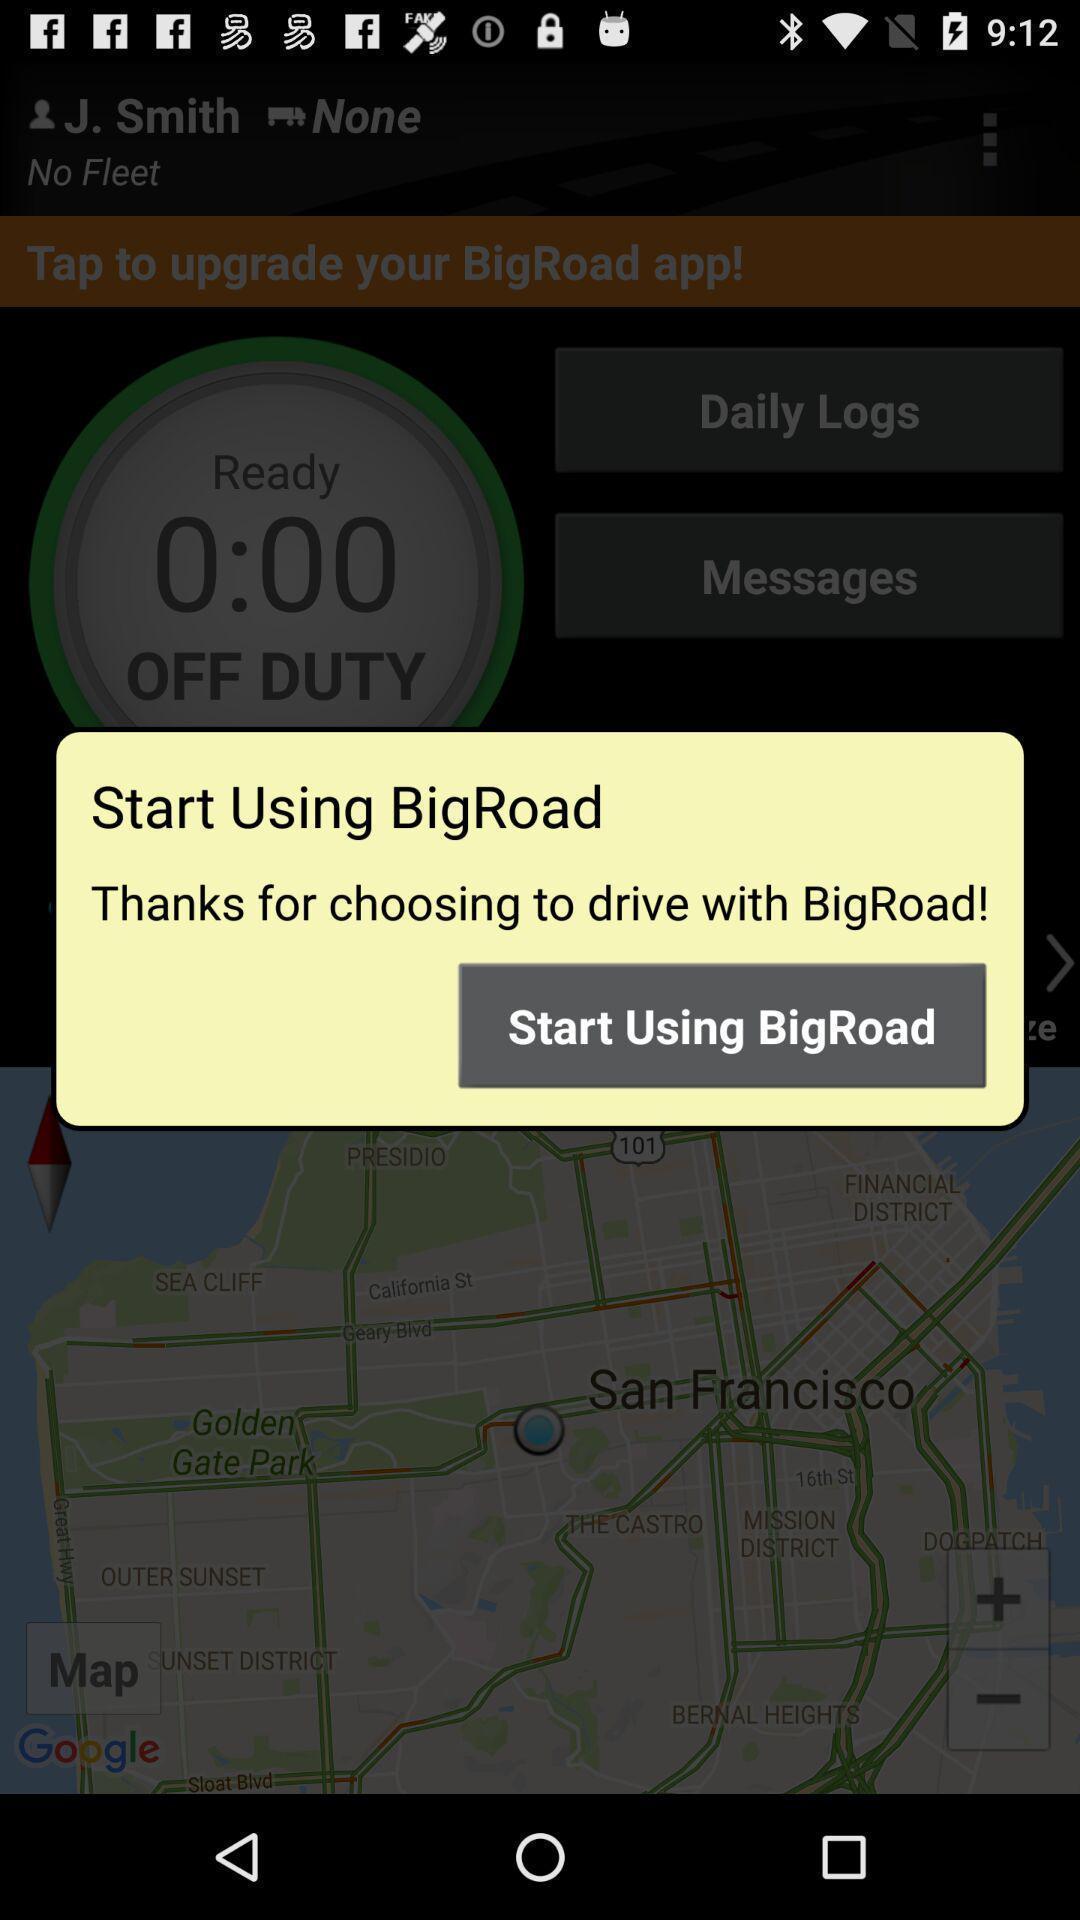What can you discern from this picture? Pop-up message to start using the app. 